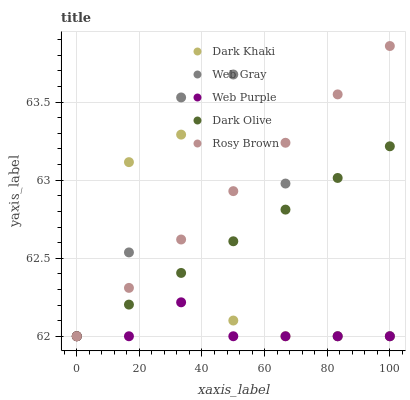Does Web Purple have the minimum area under the curve?
Answer yes or no. Yes. Does Rosy Brown have the maximum area under the curve?
Answer yes or no. Yes. Does Web Gray have the minimum area under the curve?
Answer yes or no. No. Does Web Gray have the maximum area under the curve?
Answer yes or no. No. Is Dark Olive the smoothest?
Answer yes or no. Yes. Is Dark Khaki the roughest?
Answer yes or no. Yes. Is Web Purple the smoothest?
Answer yes or no. No. Is Web Purple the roughest?
Answer yes or no. No. Does Dark Khaki have the lowest value?
Answer yes or no. Yes. Does Rosy Brown have the highest value?
Answer yes or no. Yes. Does Web Gray have the highest value?
Answer yes or no. No. Does Web Purple intersect Rosy Brown?
Answer yes or no. Yes. Is Web Purple less than Rosy Brown?
Answer yes or no. No. Is Web Purple greater than Rosy Brown?
Answer yes or no. No. 